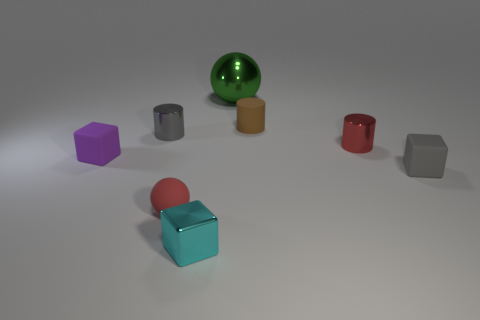Subtract all tiny purple cubes. How many cubes are left? 2 Add 2 tiny matte objects. How many objects exist? 10 Subtract all blue cubes. Subtract all blue cylinders. How many cubes are left? 3 Subtract all balls. How many objects are left? 6 Add 5 small metallic cubes. How many small metallic cubes are left? 6 Add 5 large brown shiny spheres. How many large brown shiny spheres exist? 5 Subtract 0 gray balls. How many objects are left? 8 Subtract all tiny gray metallic cylinders. Subtract all tiny gray matte cubes. How many objects are left? 6 